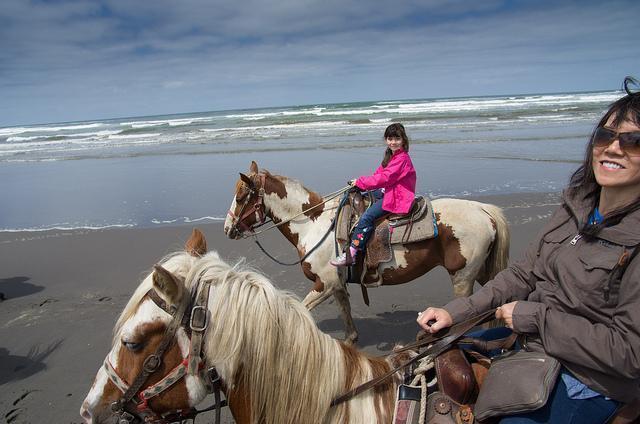How many people are in the picture?
Give a very brief answer. 2. How many horses are in the picture?
Give a very brief answer. 2. 